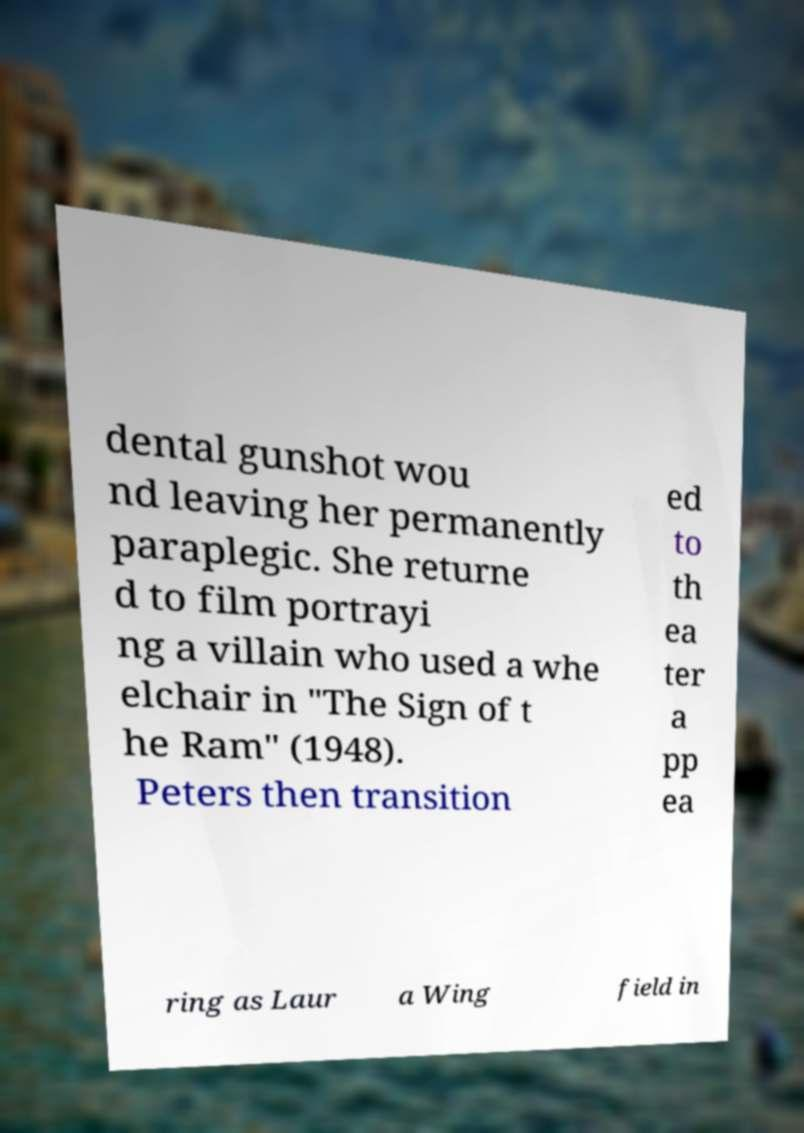Can you accurately transcribe the text from the provided image for me? dental gunshot wou nd leaving her permanently paraplegic. She returne d to film portrayi ng a villain who used a whe elchair in "The Sign of t he Ram" (1948). Peters then transition ed to th ea ter a pp ea ring as Laur a Wing field in 